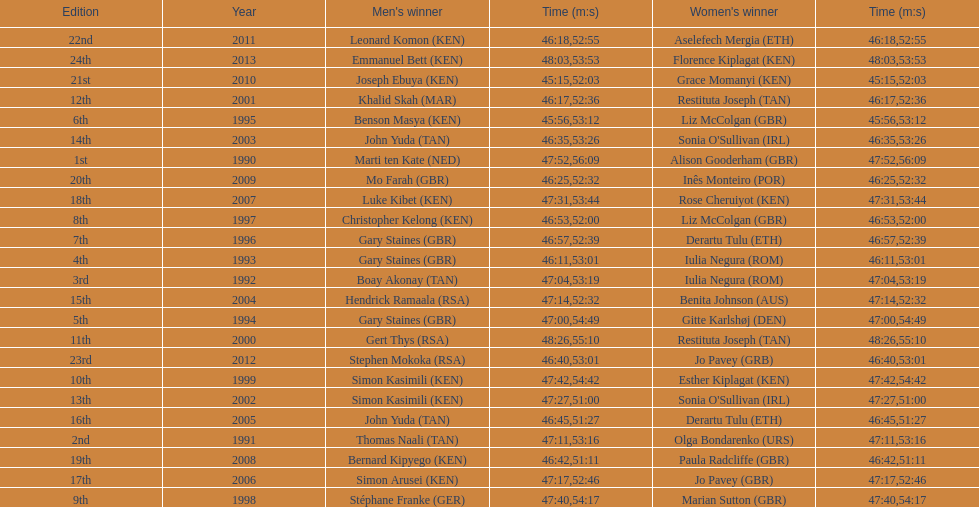Who is the male winner listed before gert thys? Simon Kasimili. 